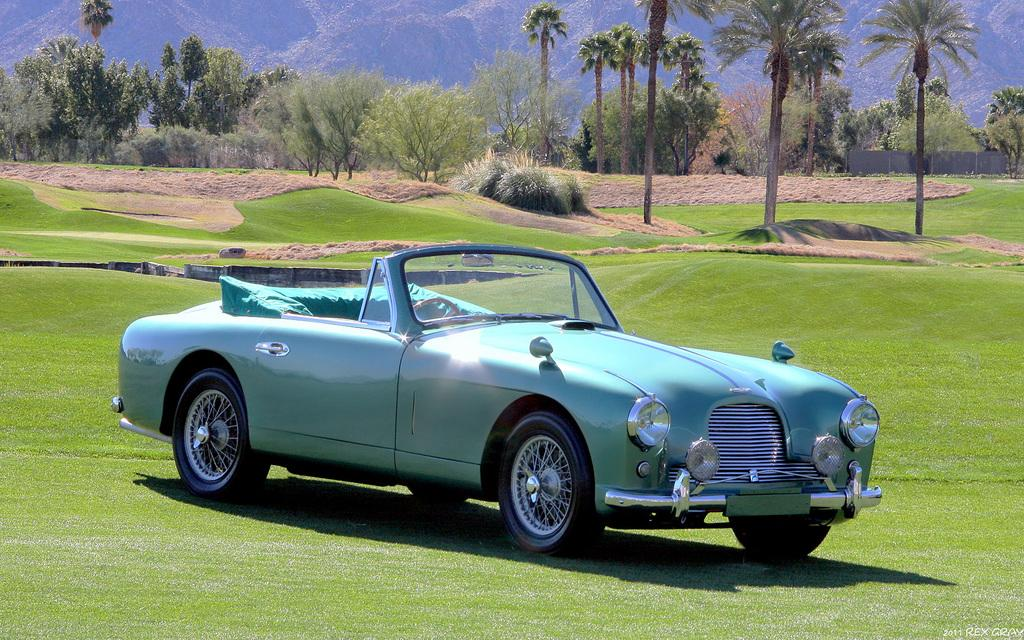What is the main subject of the image? There is a car in the image. What type of natural environment is visible in the image? There is grass, plants, trees, and hills in the image. Can you describe the landscape in the image? The image features a natural landscape with grass, plants, trees, and hills. What type of education can be seen being provided to the car in the image? There is no education being provided to the car in the image, as it is an inanimate object and cannot receive education. 